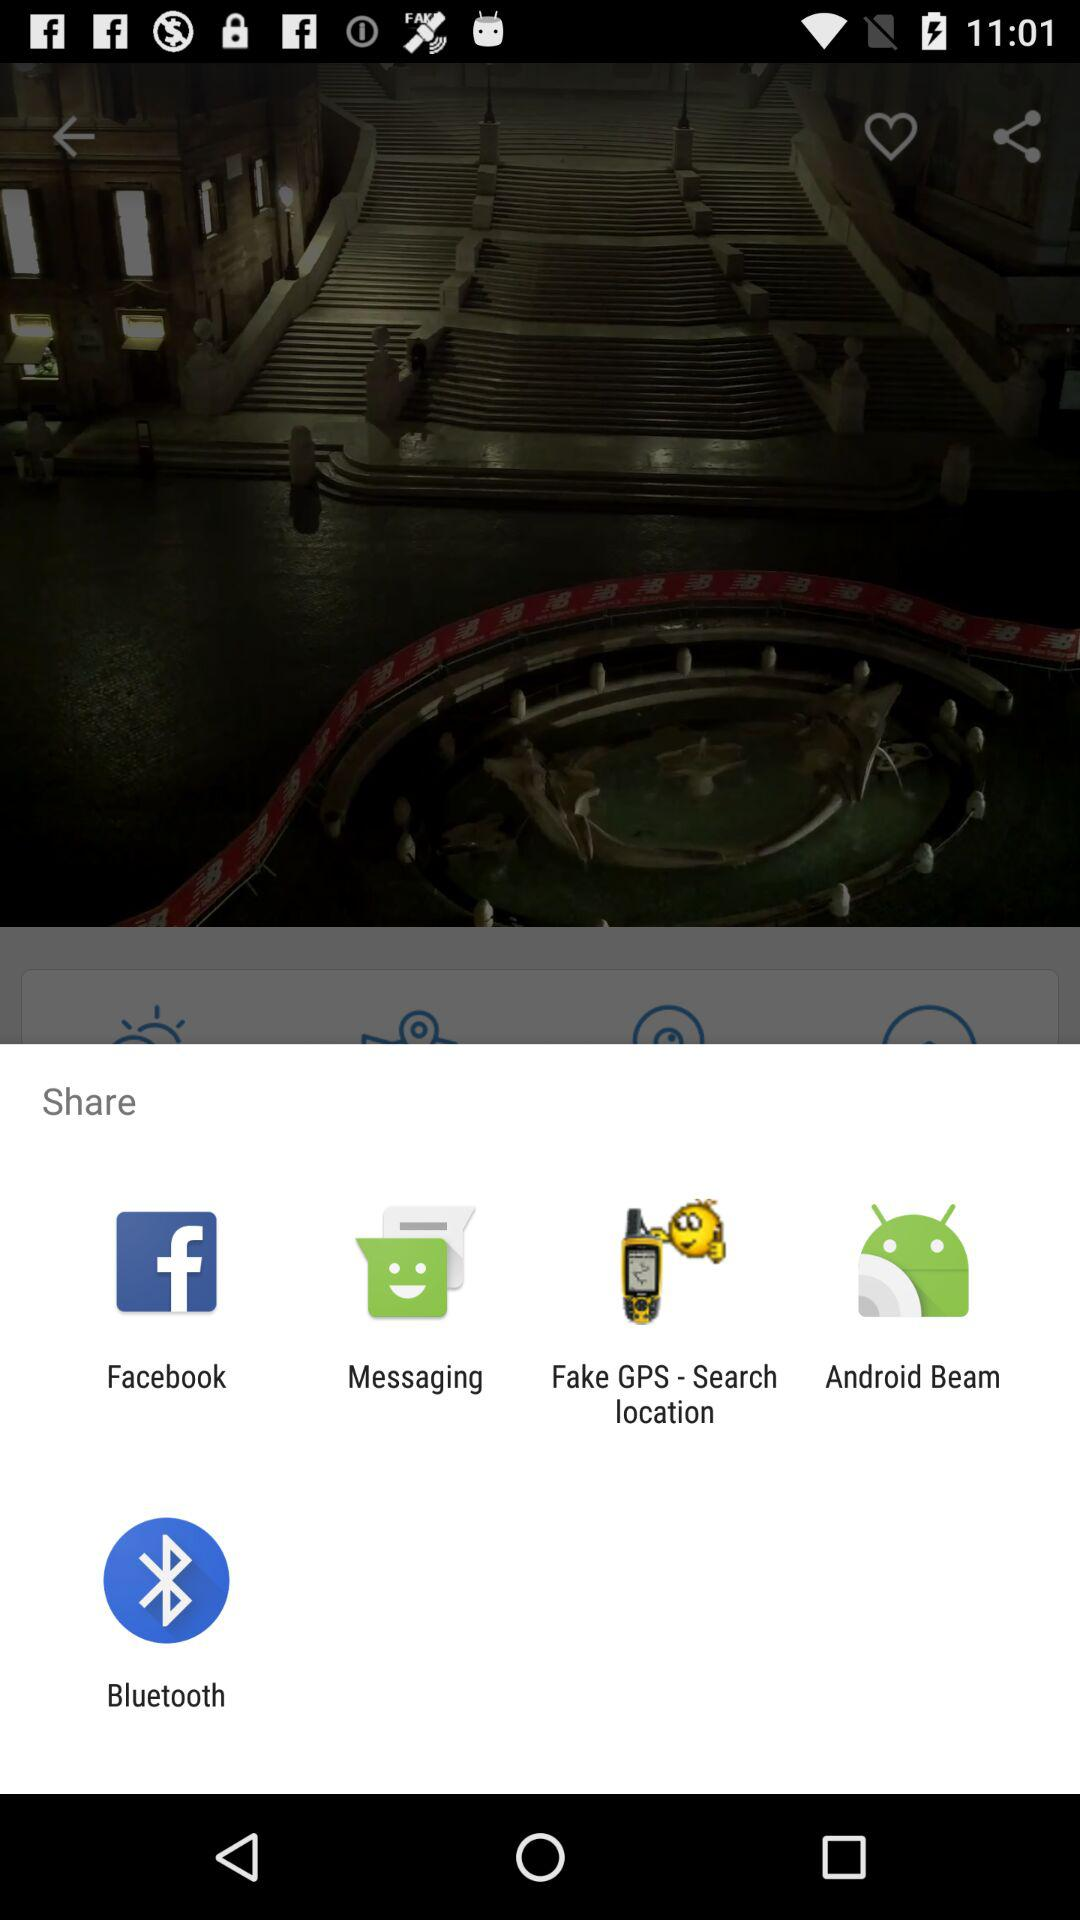What applications can be used to share? The application that can be used to share are "Facebook", "Messaging", "Fake GPS - Search location", "Android Beam" and "Bluetooth". 